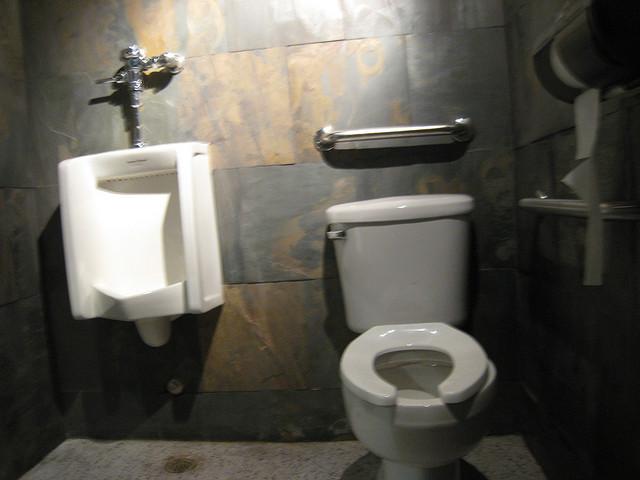Is this a men's or women's restroom?
Be succinct. Men's. Is the bathroom empty?
Answer briefly. Yes. Is there toilet paper?
Quick response, please. Yes. 